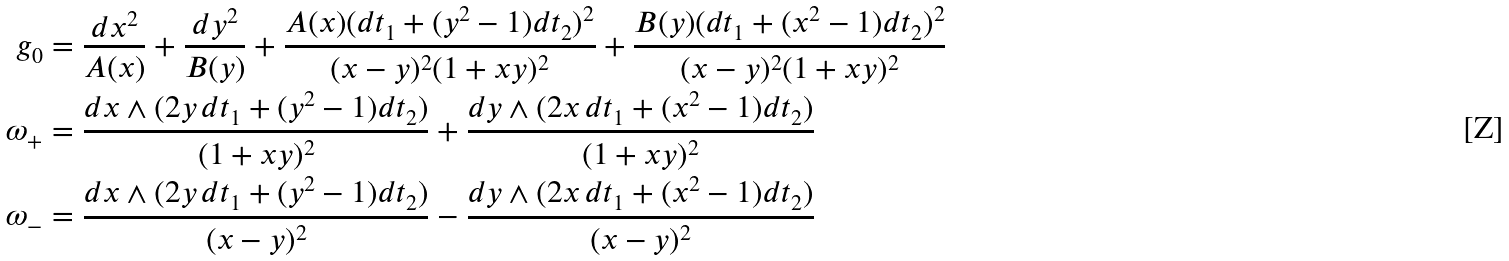Convert formula to latex. <formula><loc_0><loc_0><loc_500><loc_500>g _ { 0 } & = \frac { d x ^ { 2 } } { A ( x ) } + \frac { d y ^ { 2 } } { B ( y ) } + \frac { A ( x ) ( d t _ { 1 } + ( y ^ { 2 } - 1 ) d t _ { 2 } ) ^ { 2 } } { ( x - y ) ^ { 2 } ( 1 + x y ) ^ { 2 } } + \frac { B ( y ) ( d t _ { 1 } + ( x ^ { 2 } - 1 ) d t _ { 2 } ) ^ { 2 } } { ( x - y ) ^ { 2 } ( 1 + x y ) ^ { 2 } } \\ \omega _ { + } & = \frac { d x \wedge ( 2 y \, d t _ { 1 } + ( y ^ { 2 } - 1 ) d t _ { 2 } ) } { ( 1 + x y ) ^ { 2 } } + \frac { d y \wedge ( 2 x \, d t _ { 1 } + ( x ^ { 2 } - 1 ) d t _ { 2 } ) } { ( 1 + x y ) ^ { 2 } } \\ \omega _ { - } & = \frac { d x \wedge ( 2 y \, d t _ { 1 } + ( y ^ { 2 } - 1 ) d t _ { 2 } ) } { ( x - y ) ^ { 2 } } - \frac { d y \wedge ( 2 x \, d t _ { 1 } + ( x ^ { 2 } - 1 ) d t _ { 2 } ) } { ( x - y ) ^ { 2 } }</formula> 